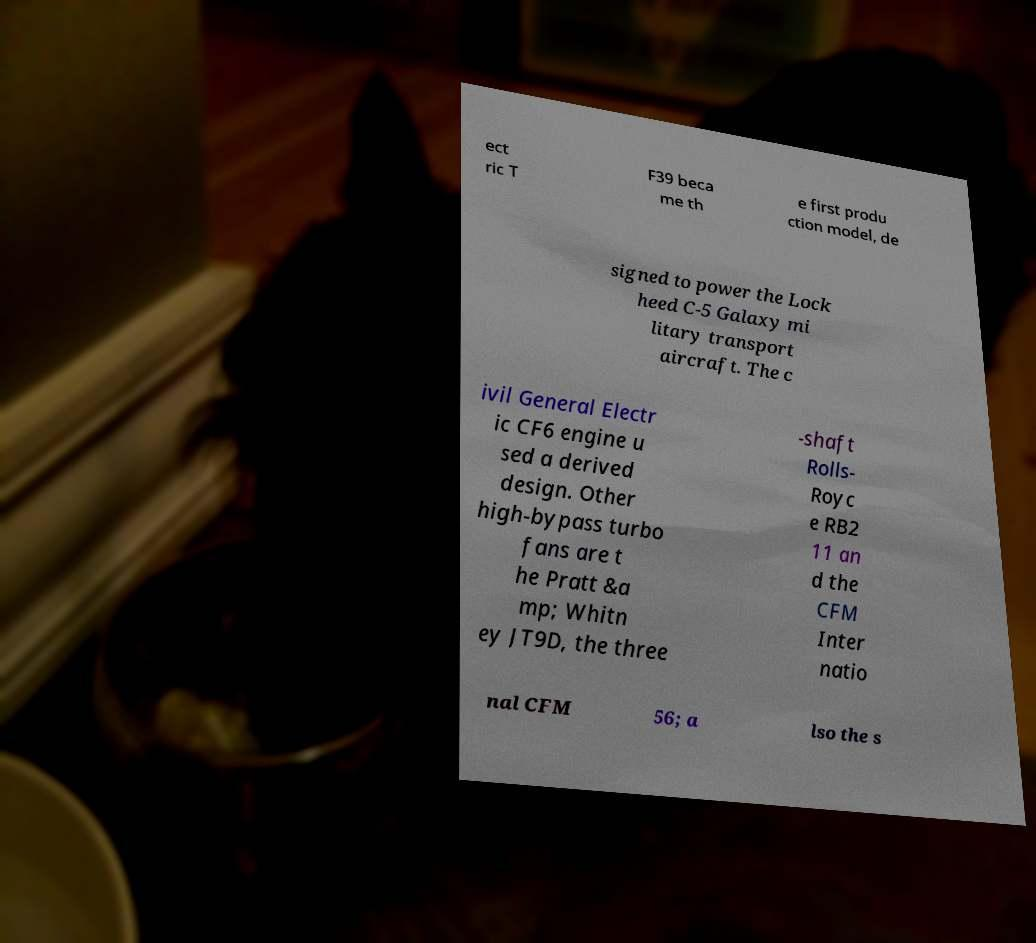Could you extract and type out the text from this image? ect ric T F39 beca me th e first produ ction model, de signed to power the Lock heed C-5 Galaxy mi litary transport aircraft. The c ivil General Electr ic CF6 engine u sed a derived design. Other high-bypass turbo fans are t he Pratt &a mp; Whitn ey JT9D, the three -shaft Rolls- Royc e RB2 11 an d the CFM Inter natio nal CFM 56; a lso the s 